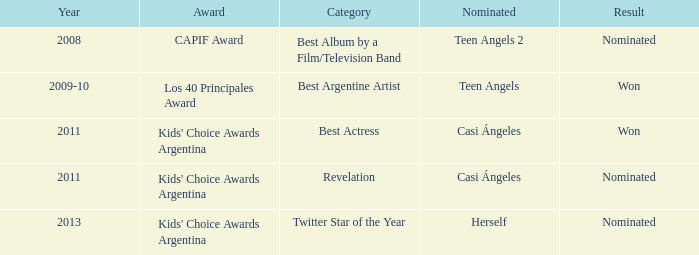In what division was herself nominated? Twitter Star of the Year. 